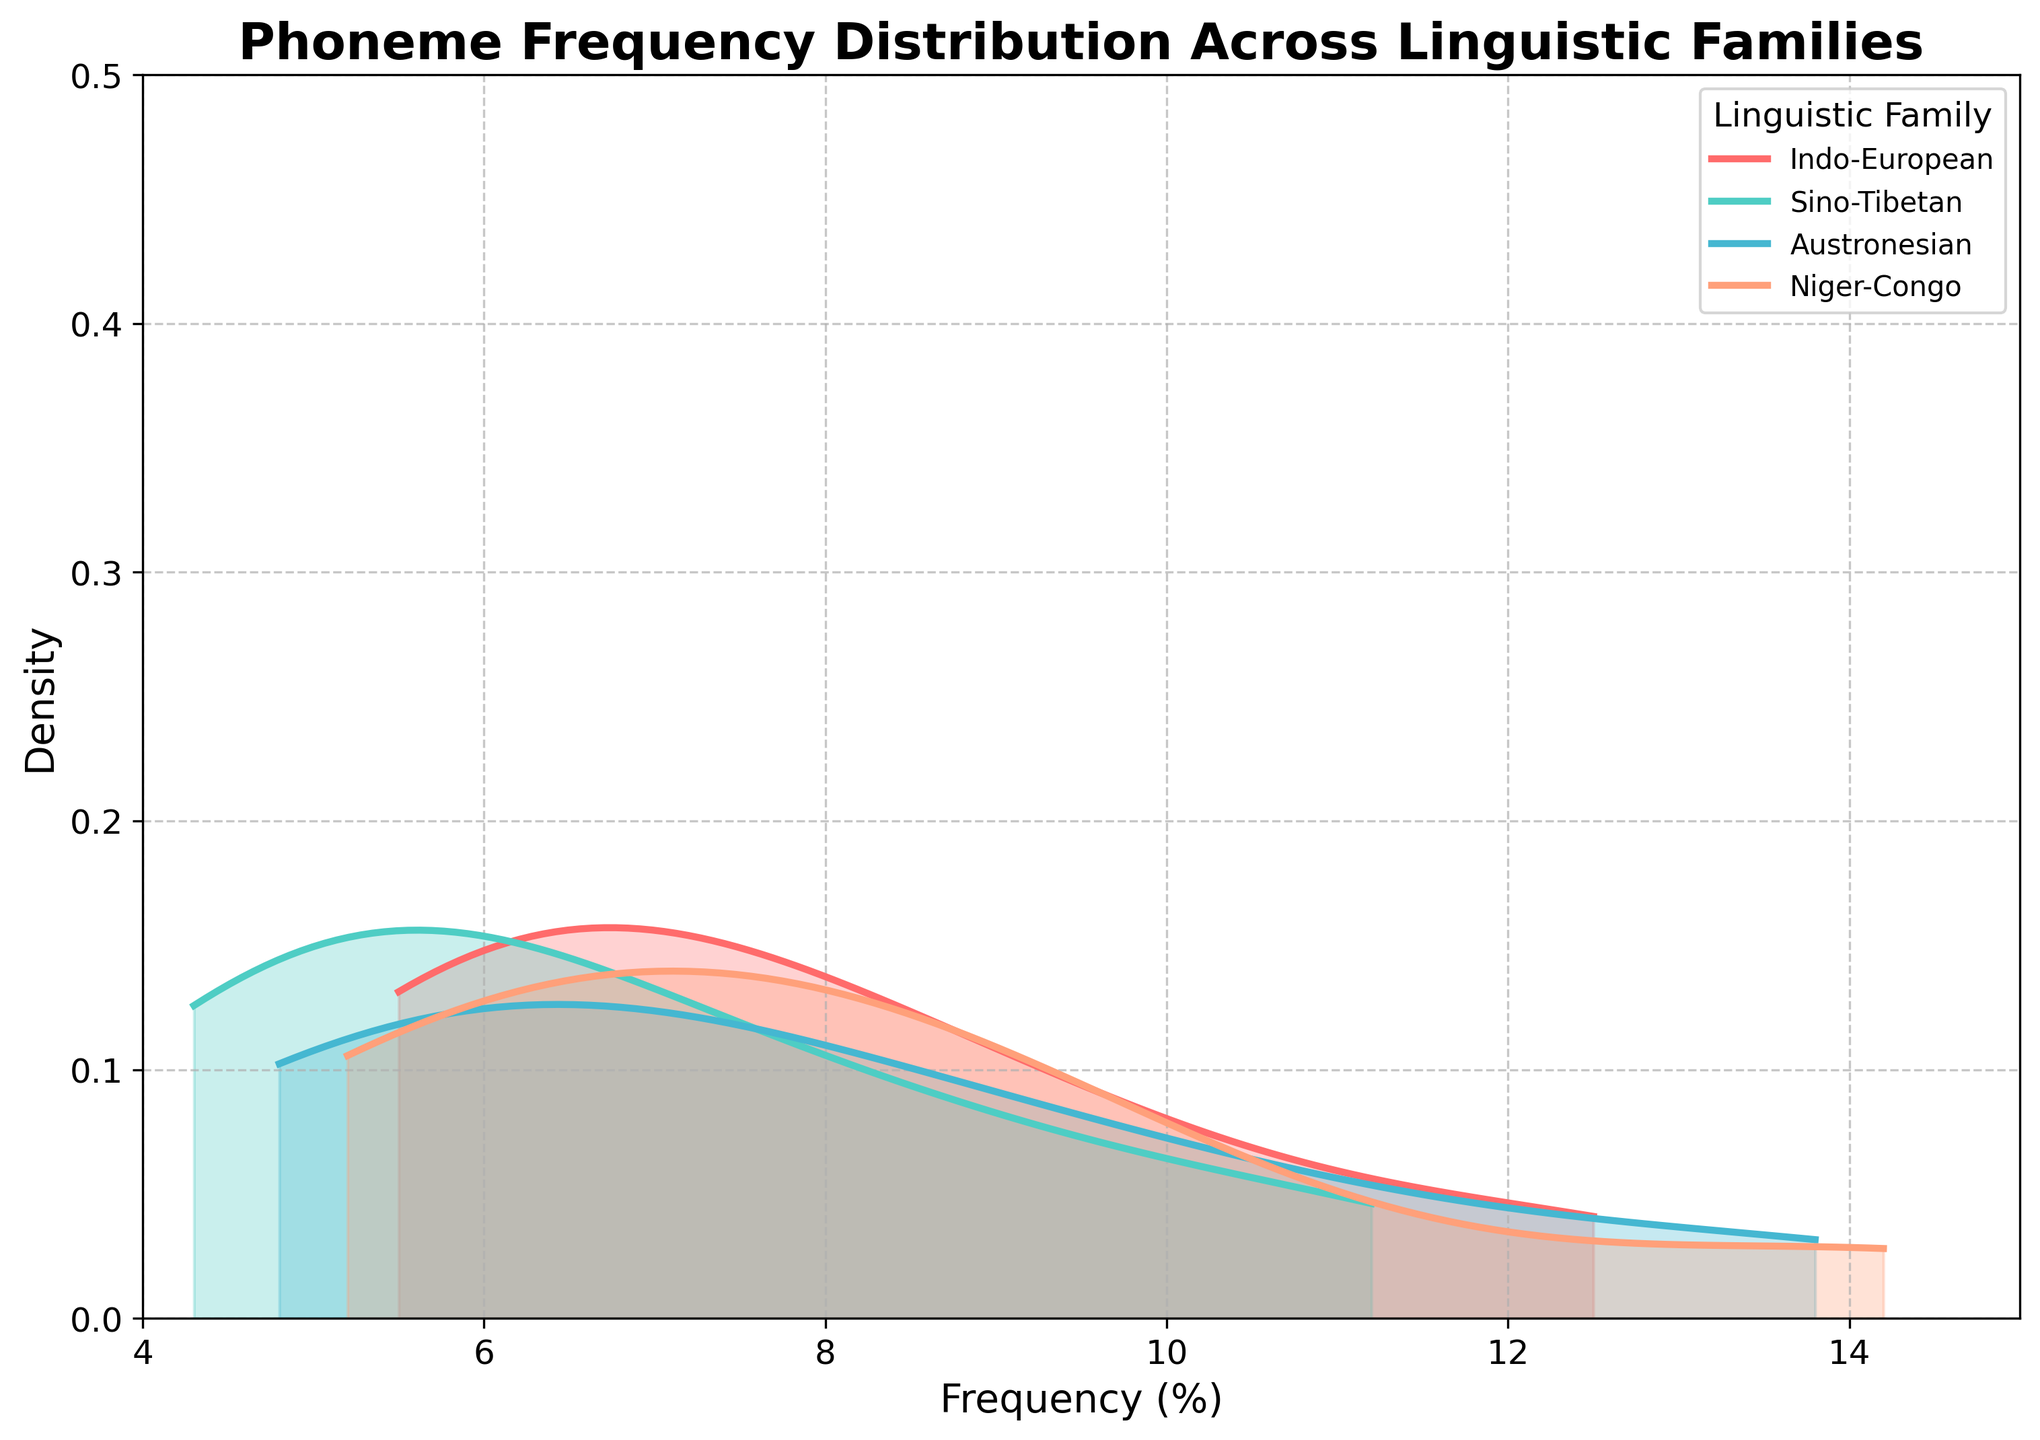What is the title of the plot? The title is located at the top center of the plot, and it provides an overview of the data being visualized.
Answer: Phoneme Frequency Distribution Across Linguistic Families How many linguistic families are compared in the plot? Check the legend on the right side of the plot; each color represents a different linguistic family.
Answer: 4 Which linguistic family shows the highest peak in density? Observe the peaks of the density plots for the different colors representing different linguistic families.
Answer: Niger-Congo At approximately what frequency range does the Niger-Congo family have its highest density? Look at the x-axis (frequency) range where the Niger-Congo density plot peaks.
Answer: 7-9% Which linguistic family has the widest range of phoneme frequencies? Compare the spread of the density plots horizontally across the x-axis for each linguistic family. The wider the spread, the wider the range of frequencies.
Answer: Indo-European What is the peak density value for the Austronesian family? Identify the highest point on the density plot for the Austronesian family by comparing all peaks.
Answer: ~0.4 Compare the density peaks of the phoneme 'a' across the linguistic families. Which family shows the highest peak for this phoneme? Notice the density lines for the phoneme 'a' and compare their heights.
Answer: Niger-Congo Between which two frequencies does the Indo-European family density plot primarily lie? Observe the Indo-European density plot and find the primary range on the x-axis.
Answer: 5.5-13.5% Which linguistic family has the lowest density for phoneme frequencies around 8%? Look at the density around the 8% mark on the x-axis and compare the heights of the density plots.
Answer: Sino-Tibetan Is there any overlap in the frequency distribution of phonemes between Austronesian and Niger-Congo families? Examine the density plots for Austronesian and Niger-Congo, and see if their shaded areas overlap.
Answer: Yes 